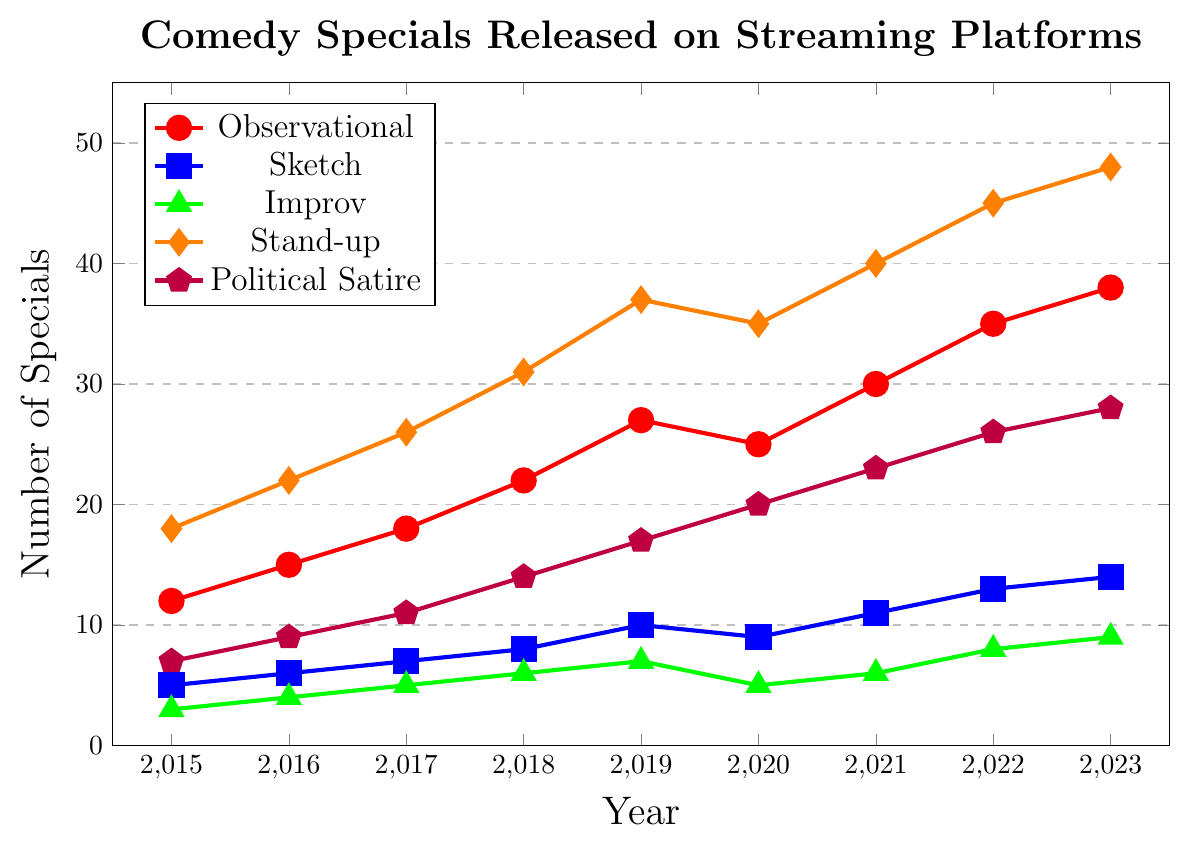What's the overall trend in the number of Observational comedy specials from 2015 to 2023? The Observational comedy specials have generally been increasing over the years from 12 in 2015 to 38 in 2023, with a small dip in 2020.
Answer: Increasing trend In which year did Political Satire comedy specials see the highest increase compared to the previous year? To find the highest increase, calculate the difference between consecutive years. The biggest increase is from 2020 to 2021 (23 - 20 = 3), 2021 to 2022 (26 - 23 = 3), or 2018 to 2019 (17 - 14 = 3). Since these 3 years have the same increase, the answer is 2020 to 2021, 2021 to 2022, and 2018 to 2019.
Answer: 2020 to 2021, 2021 to 2022, 2018 to 2019 Which sub-genre had the highest number of releases in 2023? Observing the figure for the year 2023, the Stand-up sub-genre has the highest number of releases with 48.
Answer: Stand-up Between 2018 and 2019, which sub-genre showed no change in the number of releases? Looking at the values for each sub-genre between 2018 and 2019, only Political Satire shows an increase from 14 to 17, so none have no change.
Answer: None What was the total number of comedy specials released across all sub-genres in 2018? Sum the values for all sub-genres in 2018: Observational (22) + Sketch (8) + Improv (6) + Stand-up (31) + Political Satire (14) = 81.
Answer: 81 Which sub-genre experienced a decline in the number of specials from one year to the next during the timeline? Observing the line chart data, only Observational (2020) and Improv (2020) have shown a decline, with values decreasing from 27 to 25 and from 7 to 5 respectively.
Answer: Observational, Improv Comparing Sketch and Improv sub-genres in 2020, which had more releases, and by how many? Sketch had 9 releases, and Improv had 5 releases in 2020. The difference is 9 - 5 = 4.
Answer: Sketch, 4 more What is the total increase in the number of Stand-up specials from 2015 to 2023? Subtract the number of Stand-up specials in 2015 (18) from the number in 2023 (48): 48 - 18 = 30.
Answer: 30 Which sub-genre had consistently increasing numbers every year? Observational, and Political Satire both show a consistent increase every year without any decline.
Answer: Observational, Political Satire 